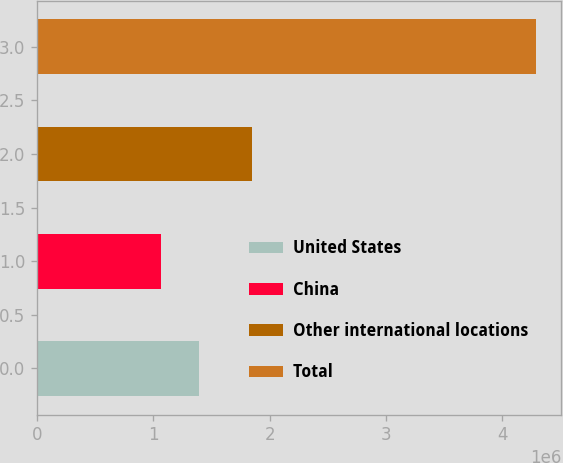Convert chart. <chart><loc_0><loc_0><loc_500><loc_500><bar_chart><fcel>United States<fcel>China<fcel>Other international locations<fcel>Total<nl><fcel>1.38776e+06<fcel>1.06506e+06<fcel>1.84732e+06<fcel>4.29206e+06<nl></chart> 